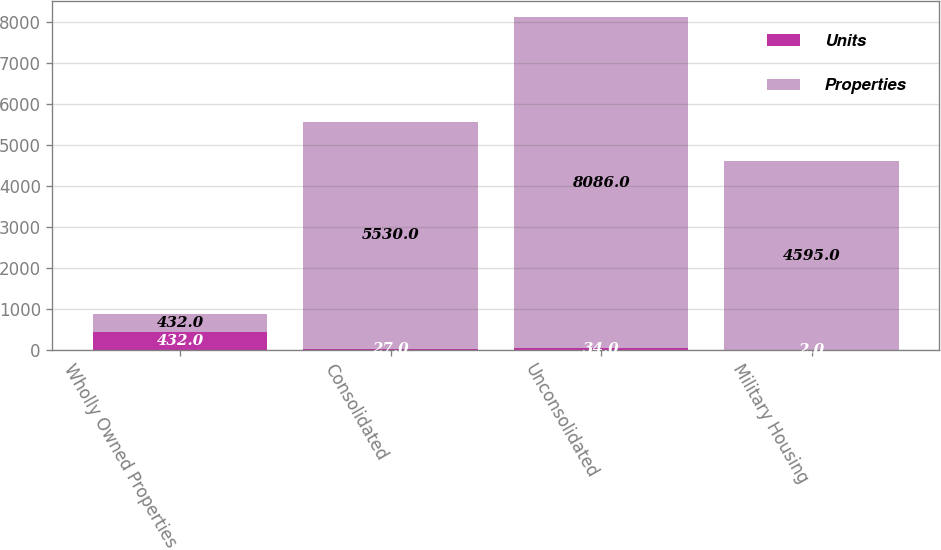<chart> <loc_0><loc_0><loc_500><loc_500><stacked_bar_chart><ecel><fcel>Wholly Owned Properties<fcel>Consolidated<fcel>Unconsolidated<fcel>Military Housing<nl><fcel>Units<fcel>432<fcel>27<fcel>34<fcel>2<nl><fcel>Properties<fcel>432<fcel>5530<fcel>8086<fcel>4595<nl></chart> 